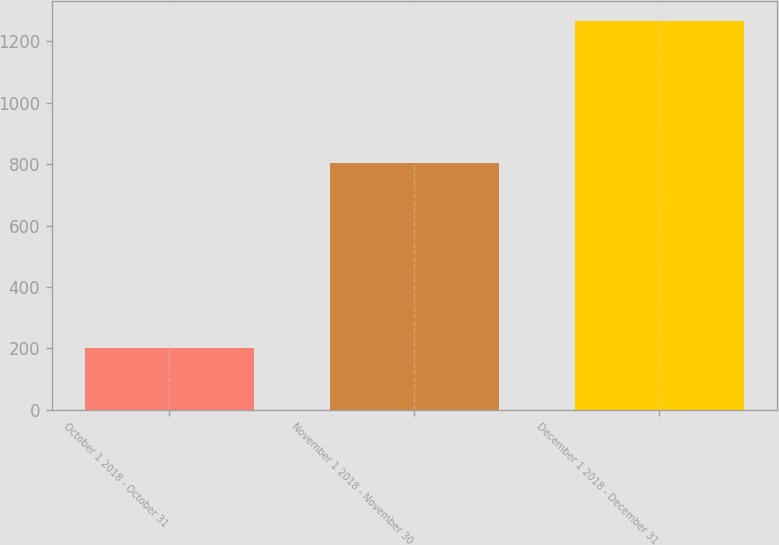Convert chart to OTSL. <chart><loc_0><loc_0><loc_500><loc_500><bar_chart><fcel>October 1 2018 - October 31<fcel>November 1 2018 - November 30<fcel>December 1 2018 - December 31<nl><fcel>200<fcel>805<fcel>1267<nl></chart> 